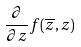<formula> <loc_0><loc_0><loc_500><loc_500>\frac { \partial } { \partial z } f ( \overline { z } , z )</formula> 